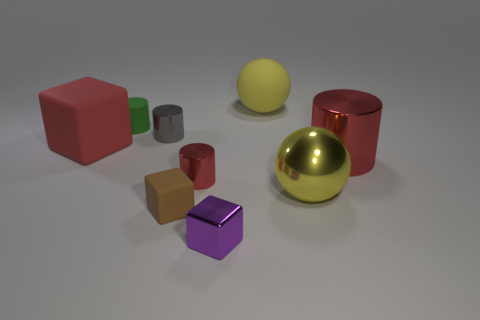Subtract all matte blocks. How many blocks are left? 1 Subtract all blue blocks. How many red cylinders are left? 2 Subtract all gray cylinders. How many cylinders are left? 3 Subtract 1 balls. How many balls are left? 1 Add 1 tiny cyan metal balls. How many objects exist? 10 Subtract 1 gray cylinders. How many objects are left? 8 Subtract all blocks. How many objects are left? 6 Subtract all gray cylinders. Subtract all red blocks. How many cylinders are left? 3 Subtract all large blue cubes. Subtract all big spheres. How many objects are left? 7 Add 2 yellow spheres. How many yellow spheres are left? 4 